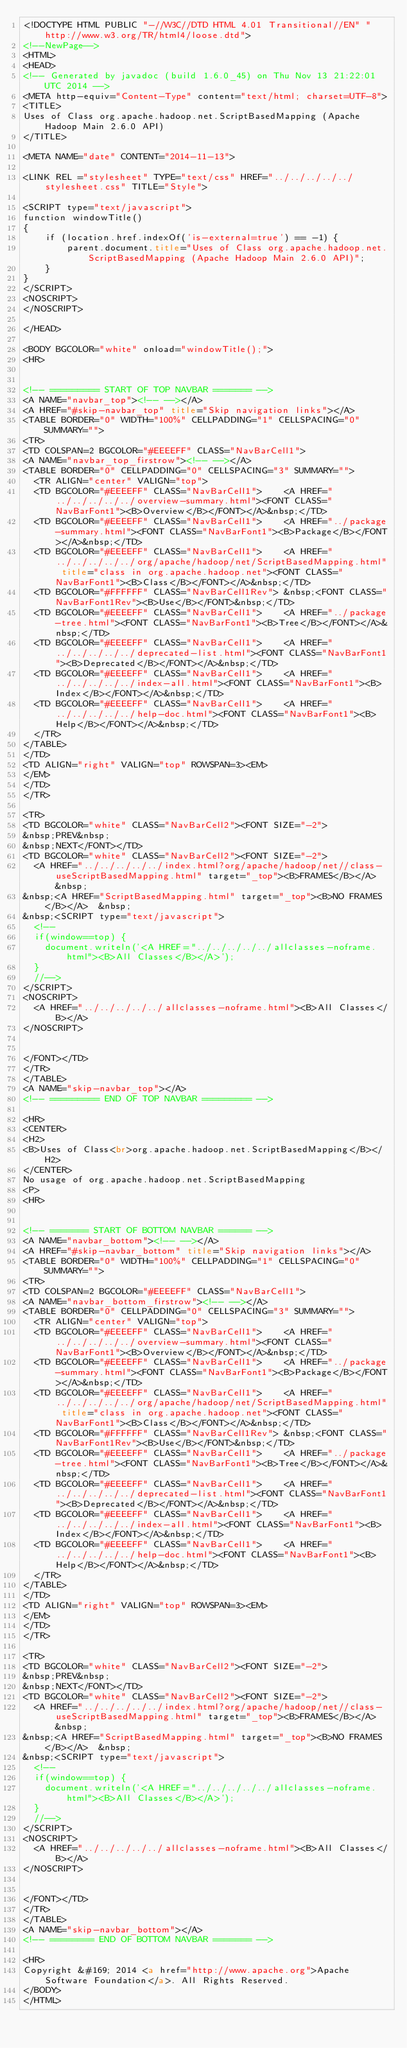<code> <loc_0><loc_0><loc_500><loc_500><_HTML_><!DOCTYPE HTML PUBLIC "-//W3C//DTD HTML 4.01 Transitional//EN" "http://www.w3.org/TR/html4/loose.dtd">
<!--NewPage-->
<HTML>
<HEAD>
<!-- Generated by javadoc (build 1.6.0_45) on Thu Nov 13 21:22:01 UTC 2014 -->
<META http-equiv="Content-Type" content="text/html; charset=UTF-8">
<TITLE>
Uses of Class org.apache.hadoop.net.ScriptBasedMapping (Apache Hadoop Main 2.6.0 API)
</TITLE>

<META NAME="date" CONTENT="2014-11-13">

<LINK REL ="stylesheet" TYPE="text/css" HREF="../../../../../stylesheet.css" TITLE="Style">

<SCRIPT type="text/javascript">
function windowTitle()
{
    if (location.href.indexOf('is-external=true') == -1) {
        parent.document.title="Uses of Class org.apache.hadoop.net.ScriptBasedMapping (Apache Hadoop Main 2.6.0 API)";
    }
}
</SCRIPT>
<NOSCRIPT>
</NOSCRIPT>

</HEAD>

<BODY BGCOLOR="white" onload="windowTitle();">
<HR>


<!-- ========= START OF TOP NAVBAR ======= -->
<A NAME="navbar_top"><!-- --></A>
<A HREF="#skip-navbar_top" title="Skip navigation links"></A>
<TABLE BORDER="0" WIDTH="100%" CELLPADDING="1" CELLSPACING="0" SUMMARY="">
<TR>
<TD COLSPAN=2 BGCOLOR="#EEEEFF" CLASS="NavBarCell1">
<A NAME="navbar_top_firstrow"><!-- --></A>
<TABLE BORDER="0" CELLPADDING="0" CELLSPACING="3" SUMMARY="">
  <TR ALIGN="center" VALIGN="top">
  <TD BGCOLOR="#EEEEFF" CLASS="NavBarCell1">    <A HREF="../../../../../overview-summary.html"><FONT CLASS="NavBarFont1"><B>Overview</B></FONT></A>&nbsp;</TD>
  <TD BGCOLOR="#EEEEFF" CLASS="NavBarCell1">    <A HREF="../package-summary.html"><FONT CLASS="NavBarFont1"><B>Package</B></FONT></A>&nbsp;</TD>
  <TD BGCOLOR="#EEEEFF" CLASS="NavBarCell1">    <A HREF="../../../../../org/apache/hadoop/net/ScriptBasedMapping.html" title="class in org.apache.hadoop.net"><FONT CLASS="NavBarFont1"><B>Class</B></FONT></A>&nbsp;</TD>
  <TD BGCOLOR="#FFFFFF" CLASS="NavBarCell1Rev"> &nbsp;<FONT CLASS="NavBarFont1Rev"><B>Use</B></FONT>&nbsp;</TD>
  <TD BGCOLOR="#EEEEFF" CLASS="NavBarCell1">    <A HREF="../package-tree.html"><FONT CLASS="NavBarFont1"><B>Tree</B></FONT></A>&nbsp;</TD>
  <TD BGCOLOR="#EEEEFF" CLASS="NavBarCell1">    <A HREF="../../../../../deprecated-list.html"><FONT CLASS="NavBarFont1"><B>Deprecated</B></FONT></A>&nbsp;</TD>
  <TD BGCOLOR="#EEEEFF" CLASS="NavBarCell1">    <A HREF="../../../../../index-all.html"><FONT CLASS="NavBarFont1"><B>Index</B></FONT></A>&nbsp;</TD>
  <TD BGCOLOR="#EEEEFF" CLASS="NavBarCell1">    <A HREF="../../../../../help-doc.html"><FONT CLASS="NavBarFont1"><B>Help</B></FONT></A>&nbsp;</TD>
  </TR>
</TABLE>
</TD>
<TD ALIGN="right" VALIGN="top" ROWSPAN=3><EM>
</EM>
</TD>
</TR>

<TR>
<TD BGCOLOR="white" CLASS="NavBarCell2"><FONT SIZE="-2">
&nbsp;PREV&nbsp;
&nbsp;NEXT</FONT></TD>
<TD BGCOLOR="white" CLASS="NavBarCell2"><FONT SIZE="-2">
  <A HREF="../../../../../index.html?org/apache/hadoop/net//class-useScriptBasedMapping.html" target="_top"><B>FRAMES</B></A>  &nbsp;
&nbsp;<A HREF="ScriptBasedMapping.html" target="_top"><B>NO FRAMES</B></A>  &nbsp;
&nbsp;<SCRIPT type="text/javascript">
  <!--
  if(window==top) {
    document.writeln('<A HREF="../../../../../allclasses-noframe.html"><B>All Classes</B></A>');
  }
  //-->
</SCRIPT>
<NOSCRIPT>
  <A HREF="../../../../../allclasses-noframe.html"><B>All Classes</B></A>
</NOSCRIPT>


</FONT></TD>
</TR>
</TABLE>
<A NAME="skip-navbar_top"></A>
<!-- ========= END OF TOP NAVBAR ========= -->

<HR>
<CENTER>
<H2>
<B>Uses of Class<br>org.apache.hadoop.net.ScriptBasedMapping</B></H2>
</CENTER>
No usage of org.apache.hadoop.net.ScriptBasedMapping
<P>
<HR>


<!-- ======= START OF BOTTOM NAVBAR ====== -->
<A NAME="navbar_bottom"><!-- --></A>
<A HREF="#skip-navbar_bottom" title="Skip navigation links"></A>
<TABLE BORDER="0" WIDTH="100%" CELLPADDING="1" CELLSPACING="0" SUMMARY="">
<TR>
<TD COLSPAN=2 BGCOLOR="#EEEEFF" CLASS="NavBarCell1">
<A NAME="navbar_bottom_firstrow"><!-- --></A>
<TABLE BORDER="0" CELLPADDING="0" CELLSPACING="3" SUMMARY="">
  <TR ALIGN="center" VALIGN="top">
  <TD BGCOLOR="#EEEEFF" CLASS="NavBarCell1">    <A HREF="../../../../../overview-summary.html"><FONT CLASS="NavBarFont1"><B>Overview</B></FONT></A>&nbsp;</TD>
  <TD BGCOLOR="#EEEEFF" CLASS="NavBarCell1">    <A HREF="../package-summary.html"><FONT CLASS="NavBarFont1"><B>Package</B></FONT></A>&nbsp;</TD>
  <TD BGCOLOR="#EEEEFF" CLASS="NavBarCell1">    <A HREF="../../../../../org/apache/hadoop/net/ScriptBasedMapping.html" title="class in org.apache.hadoop.net"><FONT CLASS="NavBarFont1"><B>Class</B></FONT></A>&nbsp;</TD>
  <TD BGCOLOR="#FFFFFF" CLASS="NavBarCell1Rev"> &nbsp;<FONT CLASS="NavBarFont1Rev"><B>Use</B></FONT>&nbsp;</TD>
  <TD BGCOLOR="#EEEEFF" CLASS="NavBarCell1">    <A HREF="../package-tree.html"><FONT CLASS="NavBarFont1"><B>Tree</B></FONT></A>&nbsp;</TD>
  <TD BGCOLOR="#EEEEFF" CLASS="NavBarCell1">    <A HREF="../../../../../deprecated-list.html"><FONT CLASS="NavBarFont1"><B>Deprecated</B></FONT></A>&nbsp;</TD>
  <TD BGCOLOR="#EEEEFF" CLASS="NavBarCell1">    <A HREF="../../../../../index-all.html"><FONT CLASS="NavBarFont1"><B>Index</B></FONT></A>&nbsp;</TD>
  <TD BGCOLOR="#EEEEFF" CLASS="NavBarCell1">    <A HREF="../../../../../help-doc.html"><FONT CLASS="NavBarFont1"><B>Help</B></FONT></A>&nbsp;</TD>
  </TR>
</TABLE>
</TD>
<TD ALIGN="right" VALIGN="top" ROWSPAN=3><EM>
</EM>
</TD>
</TR>

<TR>
<TD BGCOLOR="white" CLASS="NavBarCell2"><FONT SIZE="-2">
&nbsp;PREV&nbsp;
&nbsp;NEXT</FONT></TD>
<TD BGCOLOR="white" CLASS="NavBarCell2"><FONT SIZE="-2">
  <A HREF="../../../../../index.html?org/apache/hadoop/net//class-useScriptBasedMapping.html" target="_top"><B>FRAMES</B></A>  &nbsp;
&nbsp;<A HREF="ScriptBasedMapping.html" target="_top"><B>NO FRAMES</B></A>  &nbsp;
&nbsp;<SCRIPT type="text/javascript">
  <!--
  if(window==top) {
    document.writeln('<A HREF="../../../../../allclasses-noframe.html"><B>All Classes</B></A>');
  }
  //-->
</SCRIPT>
<NOSCRIPT>
  <A HREF="../../../../../allclasses-noframe.html"><B>All Classes</B></A>
</NOSCRIPT>


</FONT></TD>
</TR>
</TABLE>
<A NAME="skip-navbar_bottom"></A>
<!-- ======== END OF BOTTOM NAVBAR ======= -->

<HR>
Copyright &#169; 2014 <a href="http://www.apache.org">Apache Software Foundation</a>. All Rights Reserved.
</BODY>
</HTML>
</code> 